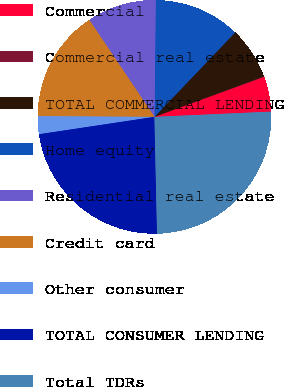Convert chart. <chart><loc_0><loc_0><loc_500><loc_500><pie_chart><fcel>Commercial<fcel>Commercial real estate<fcel>TOTAL COMMERCIAL LENDING<fcel>Home equity<fcel>Residential real estate<fcel>Credit card<fcel>Other consumer<fcel>TOTAL CONSUMER LENDING<fcel>Total TDRs<nl><fcel>4.84%<fcel>0.1%<fcel>7.21%<fcel>11.96%<fcel>9.59%<fcel>15.49%<fcel>2.47%<fcel>22.98%<fcel>25.36%<nl></chart> 